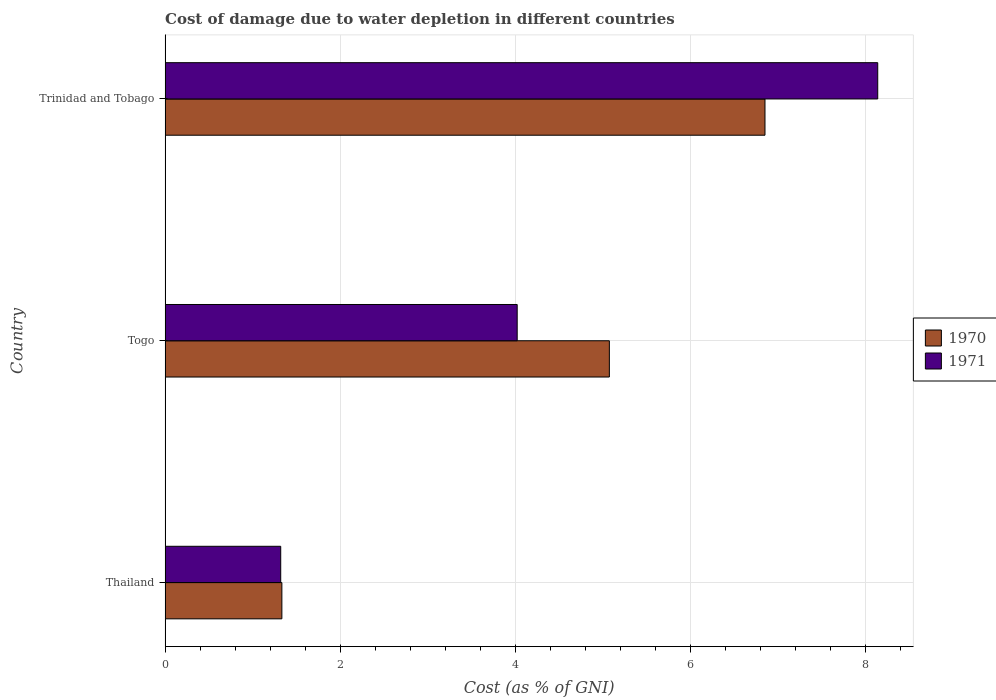How many different coloured bars are there?
Your response must be concise. 2. How many groups of bars are there?
Offer a terse response. 3. How many bars are there on the 1st tick from the top?
Your response must be concise. 2. How many bars are there on the 3rd tick from the bottom?
Ensure brevity in your answer.  2. What is the label of the 3rd group of bars from the top?
Your answer should be compact. Thailand. What is the cost of damage caused due to water depletion in 1971 in Trinidad and Tobago?
Your answer should be compact. 8.14. Across all countries, what is the maximum cost of damage caused due to water depletion in 1970?
Provide a succinct answer. 6.86. Across all countries, what is the minimum cost of damage caused due to water depletion in 1971?
Give a very brief answer. 1.32. In which country was the cost of damage caused due to water depletion in 1971 maximum?
Give a very brief answer. Trinidad and Tobago. In which country was the cost of damage caused due to water depletion in 1970 minimum?
Offer a terse response. Thailand. What is the total cost of damage caused due to water depletion in 1971 in the graph?
Offer a very short reply. 13.49. What is the difference between the cost of damage caused due to water depletion in 1970 in Togo and that in Trinidad and Tobago?
Ensure brevity in your answer.  -1.78. What is the difference between the cost of damage caused due to water depletion in 1971 in Thailand and the cost of damage caused due to water depletion in 1970 in Togo?
Provide a succinct answer. -3.76. What is the average cost of damage caused due to water depletion in 1971 per country?
Give a very brief answer. 4.5. What is the difference between the cost of damage caused due to water depletion in 1971 and cost of damage caused due to water depletion in 1970 in Togo?
Keep it short and to the point. -1.05. In how many countries, is the cost of damage caused due to water depletion in 1970 greater than 6 %?
Offer a terse response. 1. What is the ratio of the cost of damage caused due to water depletion in 1971 in Thailand to that in Trinidad and Tobago?
Your response must be concise. 0.16. Is the cost of damage caused due to water depletion in 1971 in Togo less than that in Trinidad and Tobago?
Ensure brevity in your answer.  Yes. What is the difference between the highest and the second highest cost of damage caused due to water depletion in 1970?
Provide a short and direct response. 1.78. What is the difference between the highest and the lowest cost of damage caused due to water depletion in 1971?
Ensure brevity in your answer.  6.82. In how many countries, is the cost of damage caused due to water depletion in 1971 greater than the average cost of damage caused due to water depletion in 1971 taken over all countries?
Your answer should be compact. 1. Is the sum of the cost of damage caused due to water depletion in 1970 in Thailand and Togo greater than the maximum cost of damage caused due to water depletion in 1971 across all countries?
Offer a very short reply. No. How many bars are there?
Keep it short and to the point. 6. Are all the bars in the graph horizontal?
Offer a terse response. Yes. What is the difference between two consecutive major ticks on the X-axis?
Ensure brevity in your answer.  2. Are the values on the major ticks of X-axis written in scientific E-notation?
Offer a very short reply. No. Does the graph contain any zero values?
Provide a short and direct response. No. Where does the legend appear in the graph?
Offer a terse response. Center right. How many legend labels are there?
Ensure brevity in your answer.  2. What is the title of the graph?
Provide a short and direct response. Cost of damage due to water depletion in different countries. Does "1976" appear as one of the legend labels in the graph?
Your answer should be compact. No. What is the label or title of the X-axis?
Provide a short and direct response. Cost (as % of GNI). What is the label or title of the Y-axis?
Offer a terse response. Country. What is the Cost (as % of GNI) of 1970 in Thailand?
Your response must be concise. 1.33. What is the Cost (as % of GNI) of 1971 in Thailand?
Offer a very short reply. 1.32. What is the Cost (as % of GNI) in 1970 in Togo?
Ensure brevity in your answer.  5.08. What is the Cost (as % of GNI) of 1971 in Togo?
Offer a very short reply. 4.02. What is the Cost (as % of GNI) of 1970 in Trinidad and Tobago?
Your response must be concise. 6.86. What is the Cost (as % of GNI) of 1971 in Trinidad and Tobago?
Give a very brief answer. 8.14. Across all countries, what is the maximum Cost (as % of GNI) in 1970?
Give a very brief answer. 6.86. Across all countries, what is the maximum Cost (as % of GNI) in 1971?
Ensure brevity in your answer.  8.14. Across all countries, what is the minimum Cost (as % of GNI) in 1970?
Provide a succinct answer. 1.33. Across all countries, what is the minimum Cost (as % of GNI) of 1971?
Ensure brevity in your answer.  1.32. What is the total Cost (as % of GNI) of 1970 in the graph?
Your answer should be compact. 13.27. What is the total Cost (as % of GNI) of 1971 in the graph?
Your response must be concise. 13.49. What is the difference between the Cost (as % of GNI) of 1970 in Thailand and that in Togo?
Ensure brevity in your answer.  -3.74. What is the difference between the Cost (as % of GNI) in 1971 in Thailand and that in Togo?
Offer a very short reply. -2.7. What is the difference between the Cost (as % of GNI) of 1970 in Thailand and that in Trinidad and Tobago?
Give a very brief answer. -5.52. What is the difference between the Cost (as % of GNI) in 1971 in Thailand and that in Trinidad and Tobago?
Offer a terse response. -6.82. What is the difference between the Cost (as % of GNI) in 1970 in Togo and that in Trinidad and Tobago?
Offer a very short reply. -1.78. What is the difference between the Cost (as % of GNI) of 1971 in Togo and that in Trinidad and Tobago?
Your answer should be compact. -4.12. What is the difference between the Cost (as % of GNI) of 1970 in Thailand and the Cost (as % of GNI) of 1971 in Togo?
Ensure brevity in your answer.  -2.69. What is the difference between the Cost (as % of GNI) of 1970 in Thailand and the Cost (as % of GNI) of 1971 in Trinidad and Tobago?
Give a very brief answer. -6.81. What is the difference between the Cost (as % of GNI) in 1970 in Togo and the Cost (as % of GNI) in 1971 in Trinidad and Tobago?
Provide a succinct answer. -3.07. What is the average Cost (as % of GNI) in 1970 per country?
Keep it short and to the point. 4.42. What is the average Cost (as % of GNI) of 1971 per country?
Your answer should be very brief. 4.5. What is the difference between the Cost (as % of GNI) of 1970 and Cost (as % of GNI) of 1971 in Thailand?
Ensure brevity in your answer.  0.01. What is the difference between the Cost (as % of GNI) of 1970 and Cost (as % of GNI) of 1971 in Togo?
Your response must be concise. 1.05. What is the difference between the Cost (as % of GNI) in 1970 and Cost (as % of GNI) in 1971 in Trinidad and Tobago?
Give a very brief answer. -1.29. What is the ratio of the Cost (as % of GNI) of 1970 in Thailand to that in Togo?
Keep it short and to the point. 0.26. What is the ratio of the Cost (as % of GNI) of 1971 in Thailand to that in Togo?
Your answer should be very brief. 0.33. What is the ratio of the Cost (as % of GNI) in 1970 in Thailand to that in Trinidad and Tobago?
Your response must be concise. 0.19. What is the ratio of the Cost (as % of GNI) of 1971 in Thailand to that in Trinidad and Tobago?
Make the answer very short. 0.16. What is the ratio of the Cost (as % of GNI) of 1970 in Togo to that in Trinidad and Tobago?
Your response must be concise. 0.74. What is the ratio of the Cost (as % of GNI) in 1971 in Togo to that in Trinidad and Tobago?
Your response must be concise. 0.49. What is the difference between the highest and the second highest Cost (as % of GNI) of 1970?
Your response must be concise. 1.78. What is the difference between the highest and the second highest Cost (as % of GNI) in 1971?
Offer a very short reply. 4.12. What is the difference between the highest and the lowest Cost (as % of GNI) in 1970?
Your answer should be very brief. 5.52. What is the difference between the highest and the lowest Cost (as % of GNI) of 1971?
Your response must be concise. 6.82. 